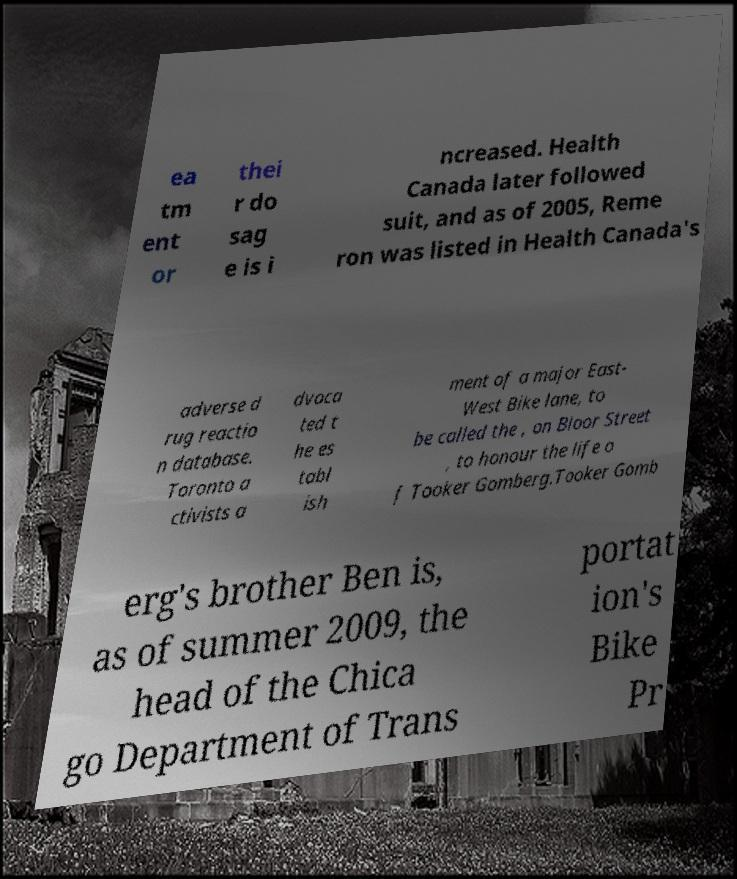I need the written content from this picture converted into text. Can you do that? ea tm ent or thei r do sag e is i ncreased. Health Canada later followed suit, and as of 2005, Reme ron was listed in Health Canada's adverse d rug reactio n database. Toronto a ctivists a dvoca ted t he es tabl ish ment of a major East- West Bike lane, to be called the , on Bloor Street , to honour the life o f Tooker Gomberg.Tooker Gomb erg's brother Ben is, as of summer 2009, the head of the Chica go Department of Trans portat ion's Bike Pr 